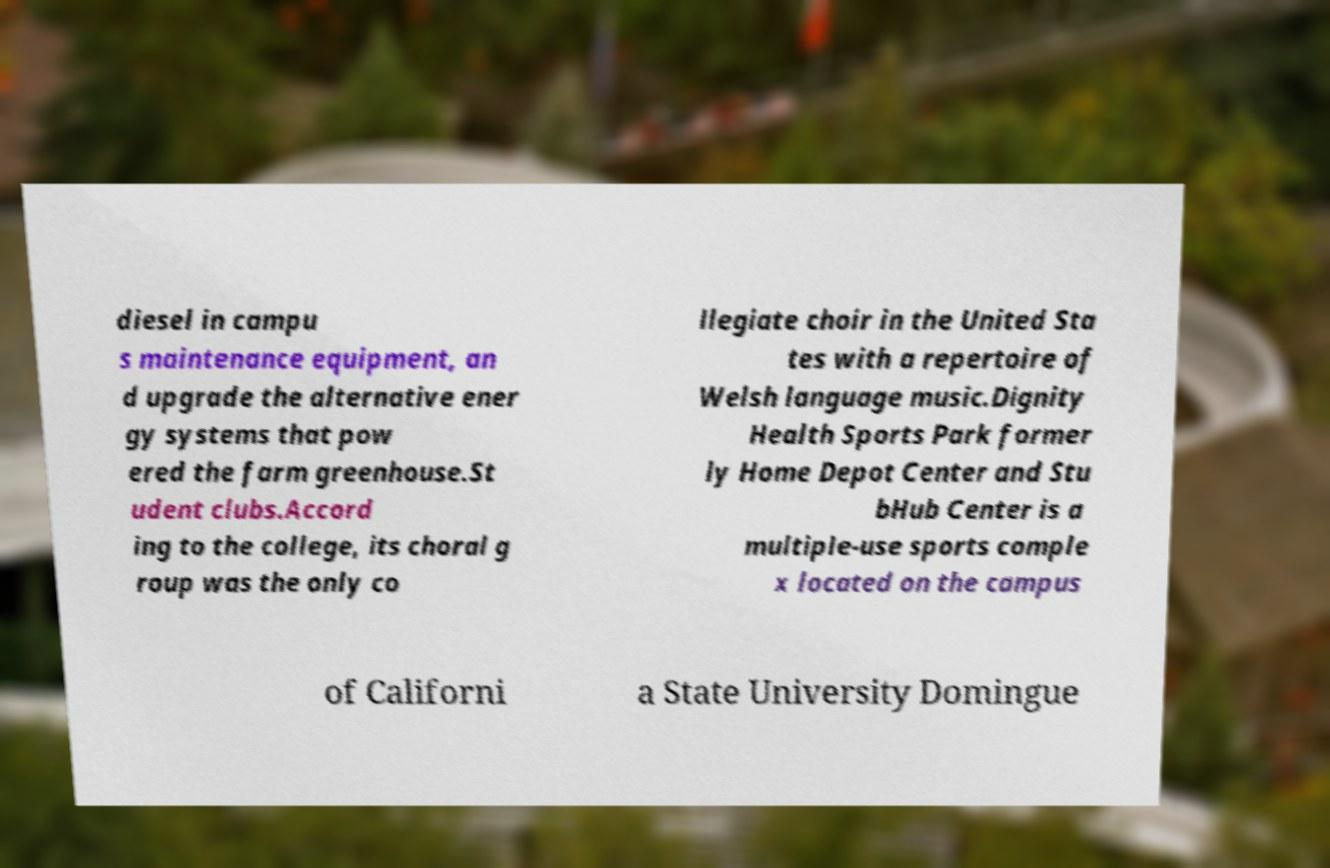I need the written content from this picture converted into text. Can you do that? diesel in campu s maintenance equipment, an d upgrade the alternative ener gy systems that pow ered the farm greenhouse.St udent clubs.Accord ing to the college, its choral g roup was the only co llegiate choir in the United Sta tes with a repertoire of Welsh language music.Dignity Health Sports Park former ly Home Depot Center and Stu bHub Center is a multiple-use sports comple x located on the campus of Californi a State University Domingue 